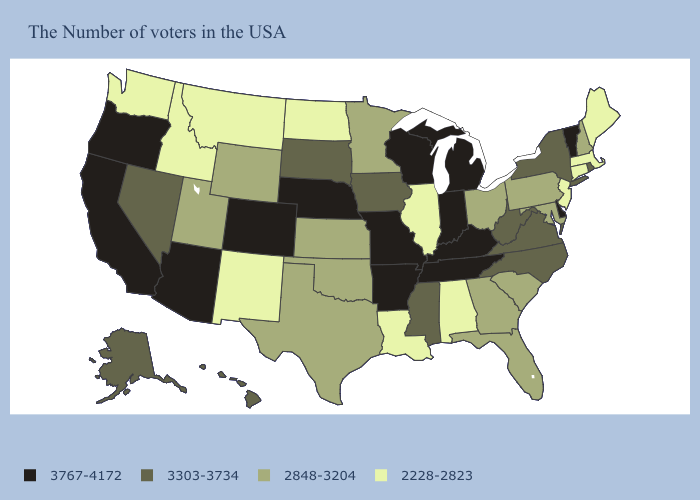Name the states that have a value in the range 3303-3734?
Keep it brief. Rhode Island, New York, Virginia, North Carolina, West Virginia, Mississippi, Iowa, South Dakota, Nevada, Alaska, Hawaii. Does Kansas have a higher value than New Jersey?
Give a very brief answer. Yes. Which states hav the highest value in the MidWest?
Quick response, please. Michigan, Indiana, Wisconsin, Missouri, Nebraska. Which states have the lowest value in the MidWest?
Concise answer only. Illinois, North Dakota. What is the value of Illinois?
Give a very brief answer. 2228-2823. What is the value of New Jersey?
Write a very short answer. 2228-2823. Does New York have the highest value in the Northeast?
Write a very short answer. No. Among the states that border Kansas , does Oklahoma have the highest value?
Write a very short answer. No. How many symbols are there in the legend?
Quick response, please. 4. What is the lowest value in states that border New Mexico?
Concise answer only. 2848-3204. What is the value of Tennessee?
Short answer required. 3767-4172. Does Vermont have the highest value in the USA?
Keep it brief. Yes. Name the states that have a value in the range 3767-4172?
Be succinct. Vermont, Delaware, Michigan, Kentucky, Indiana, Tennessee, Wisconsin, Missouri, Arkansas, Nebraska, Colorado, Arizona, California, Oregon. What is the value of South Dakota?
Short answer required. 3303-3734. Among the states that border North Dakota , does Minnesota have the lowest value?
Keep it brief. No. 